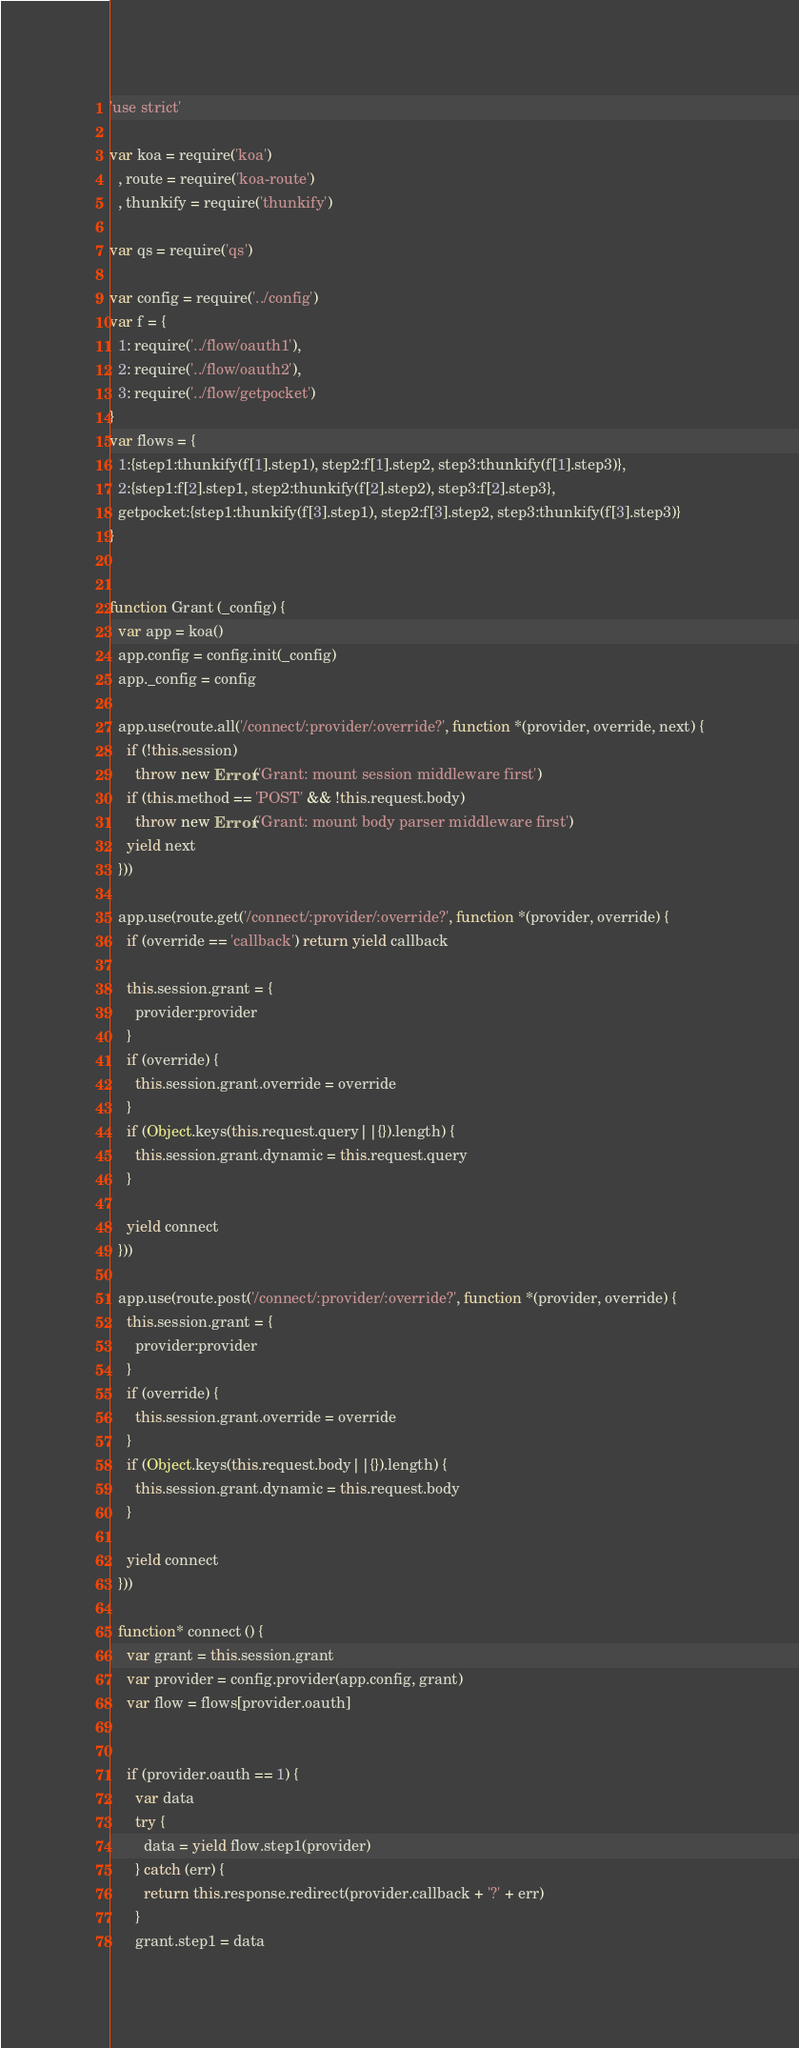Convert code to text. <code><loc_0><loc_0><loc_500><loc_500><_JavaScript_>'use strict'

var koa = require('koa')
  , route = require('koa-route')
  , thunkify = require('thunkify')

var qs = require('qs')

var config = require('../config')
var f = {
  1: require('../flow/oauth1'),
  2: require('../flow/oauth2'),
  3: require('../flow/getpocket')
}
var flows = {
  1:{step1:thunkify(f[1].step1), step2:f[1].step2, step3:thunkify(f[1].step3)},
  2:{step1:f[2].step1, step2:thunkify(f[2].step2), step3:f[2].step3},
  getpocket:{step1:thunkify(f[3].step1), step2:f[3].step2, step3:thunkify(f[3].step3)}
}


function Grant (_config) {
  var app = koa()
  app.config = config.init(_config)
  app._config = config

  app.use(route.all('/connect/:provider/:override?', function *(provider, override, next) {
    if (!this.session)
      throw new Error('Grant: mount session middleware first')
    if (this.method == 'POST' && !this.request.body)
      throw new Error('Grant: mount body parser middleware first')
    yield next
  }))

  app.use(route.get('/connect/:provider/:override?', function *(provider, override) {
    if (override == 'callback') return yield callback

    this.session.grant = {
      provider:provider
    }
    if (override) {
      this.session.grant.override = override
    }
    if (Object.keys(this.request.query||{}).length) {
      this.session.grant.dynamic = this.request.query
    }

    yield connect
  }))

  app.use(route.post('/connect/:provider/:override?', function *(provider, override) {
    this.session.grant = {
      provider:provider
    }
    if (override) {
      this.session.grant.override = override
    }
    if (Object.keys(this.request.body||{}).length) {
      this.session.grant.dynamic = this.request.body
    }

    yield connect
  }))

  function* connect () {
    var grant = this.session.grant
    var provider = config.provider(app.config, grant)
    var flow = flows[provider.oauth]


    if (provider.oauth == 1) {
      var data
      try {
        data = yield flow.step1(provider)
      } catch (err) {
        return this.response.redirect(provider.callback + '?' + err)
      }
      grant.step1 = data</code> 